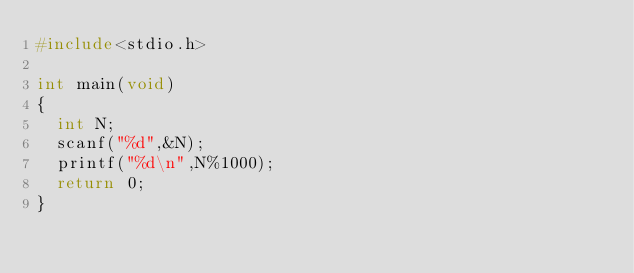Convert code to text. <code><loc_0><loc_0><loc_500><loc_500><_C++_>#include<stdio.h>
 
int main(void)
{
  int N;
  scanf("%d",&N);
  printf("%d\n",N%1000);
  return 0;
}</code> 